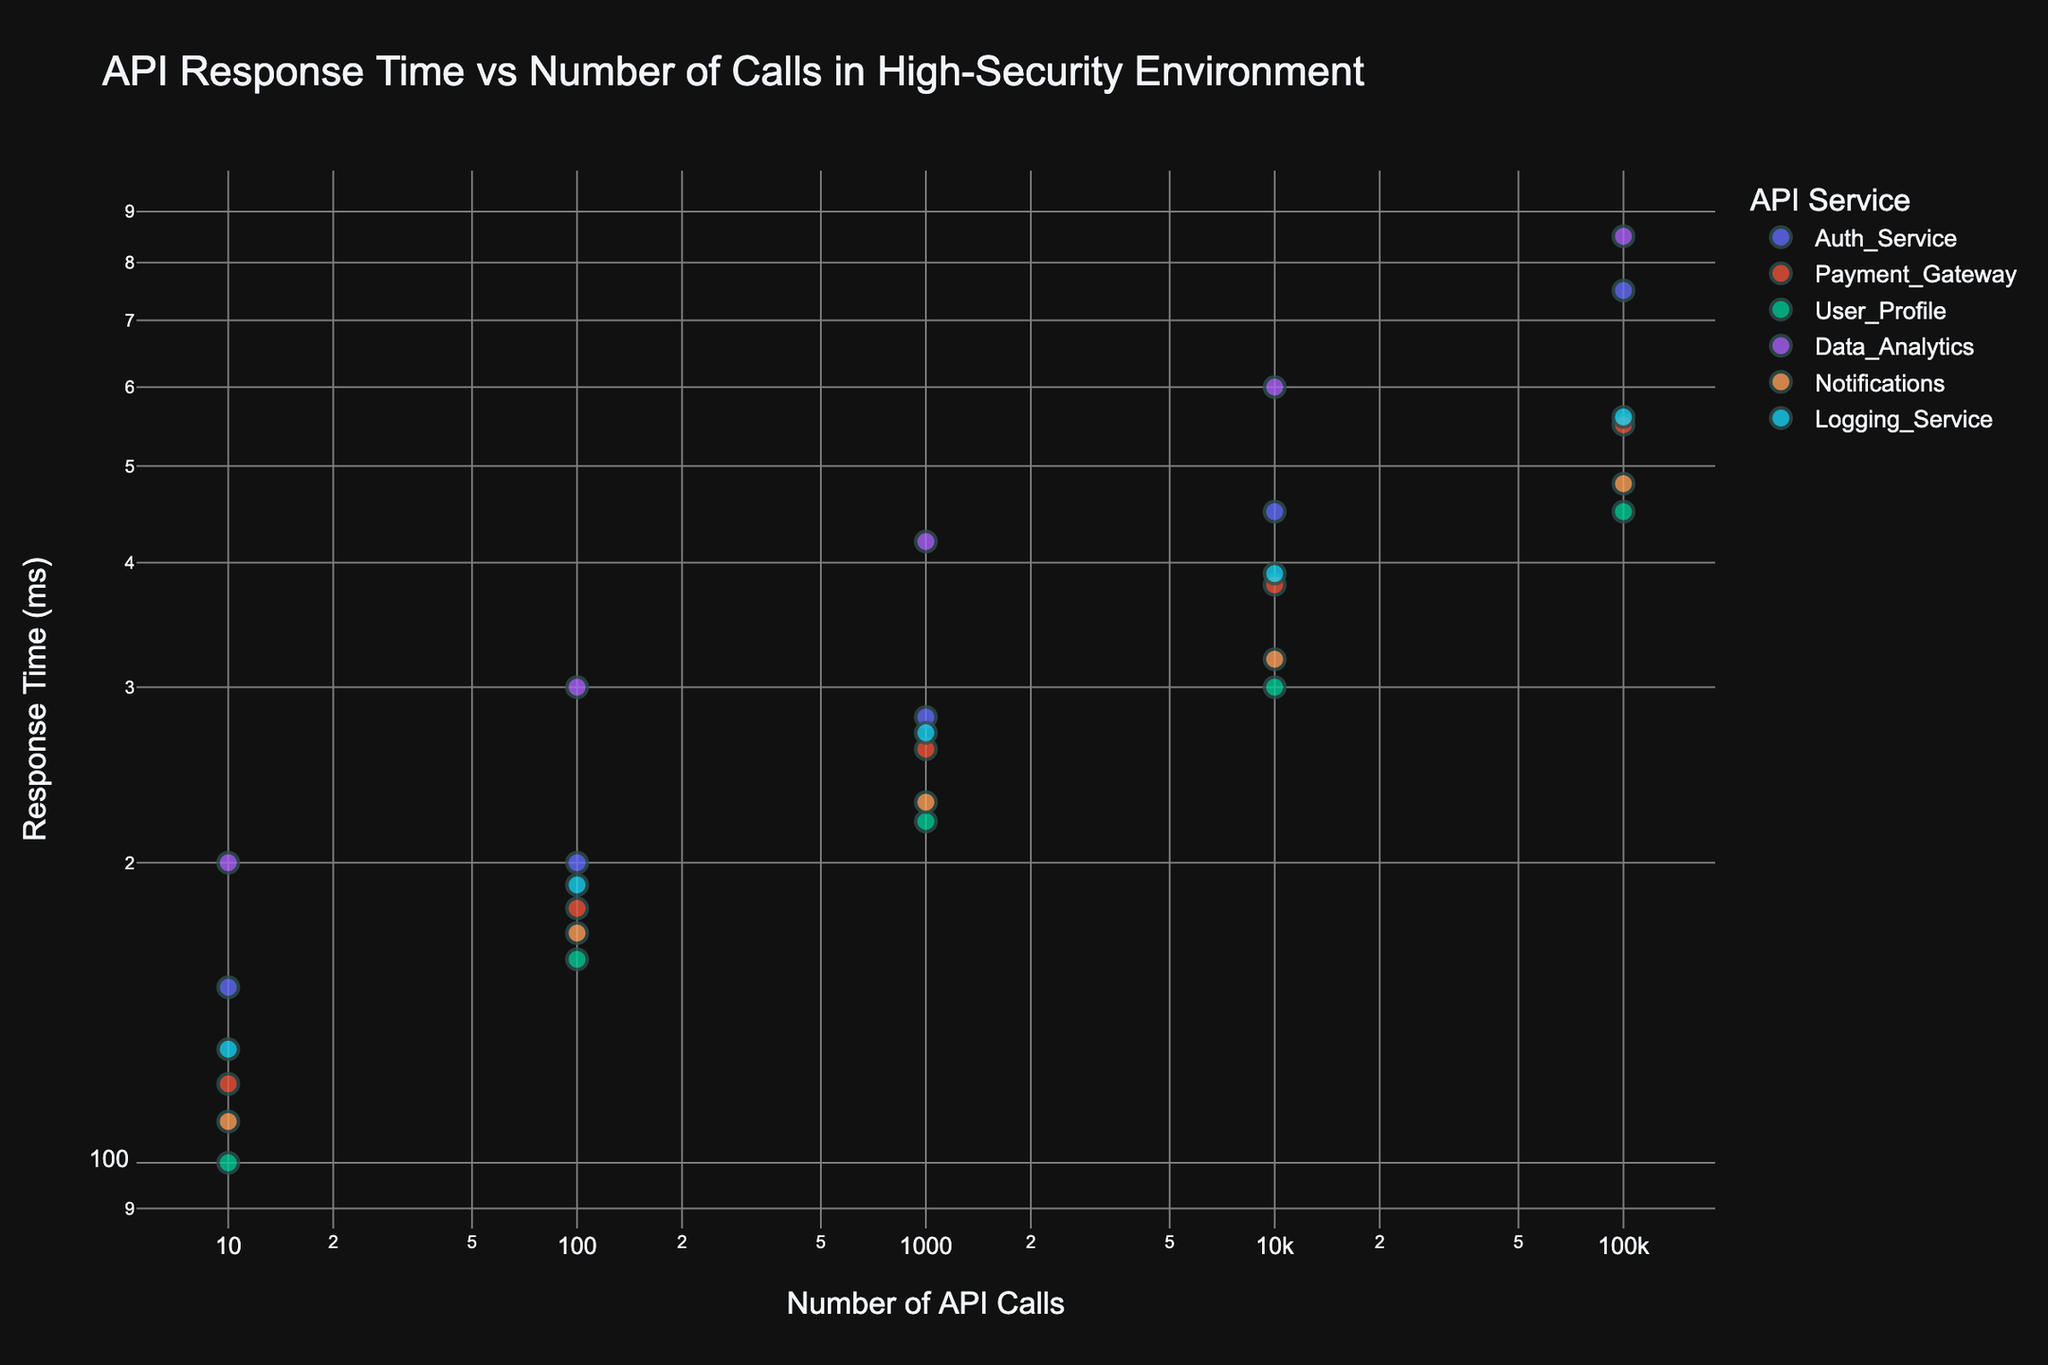What's the title of the figure? The title is typically placed at the top center of the chart. Here, it reads "API Response Time vs Number of Calls in High-Security Environment".
Answer: API Response Time vs Number of Calls in High-Security Environment How many unique APIs are represented in the figure? You can identify the number of unique APIs by looking at the legend which lists them by color. There are six unique APIs: Auth_Service, Payment_Gateway, User_Profile, Data_Analytics, Notifications, and Logging_Service.
Answer: 6 Which API has the highest response time for 100,000 API calls? By examining the data points for 100,000 API calls on the log scaled x-axis and their corresponding response times on the y-axis, the Data_Analytics API has the highest response time.
Answer: Data_Analytics What is the response time difference between Auth_Service and User_Profile for 10,000 API calls? Locate the data points for Auth_Service and User_Profile at 10,000 API calls. From the y-axis, Auth_Service has a response time of 450 ms and User_Profile has 300 ms. The difference is 450 - 300.
Answer: 150 ms Which API exhibits the largest increase in response time as the number of API calls increases from 10 to 1,000 calls? By comparing the trajectory of data points for each API on the log scale, the Data_Analytics service shows the steepest increase in response time, starting from 200 ms at 10 calls to 420 ms at 1,000 calls.
Answer: Data_Analytics For which API is the response time most consistent irrespective of the number of API calls? By examining the spread and slope of the data points, the User_Profile API appears to be most consistent, showing a relatively stable increase in response time.
Answer: User_Profile Between Payment_Gateway and Notifications, which has a better response time at 1,000 API calls? Locate the data points for both APIs at 1,000 API calls. Payment_Gateway has a response time of 260 ms, whereas Notifications has 230 ms. The better (shorter) response time is for Notifications.
Answer: Notifications What trend in response time is observed as the number of API calls increases across all APIs? Across all APIs, as the number of API calls increases, the response time also increases. This is represented by the upward slope of the data points on the log-log scale.
Answer: Response time increases What is the visual appearance of data points on the plot? The data points are represented as markers that vary in color based on the API they represent. They have consistent size and lines, with grid lines visible in the background for both axes.
Answer: Colored markers with grid lines 